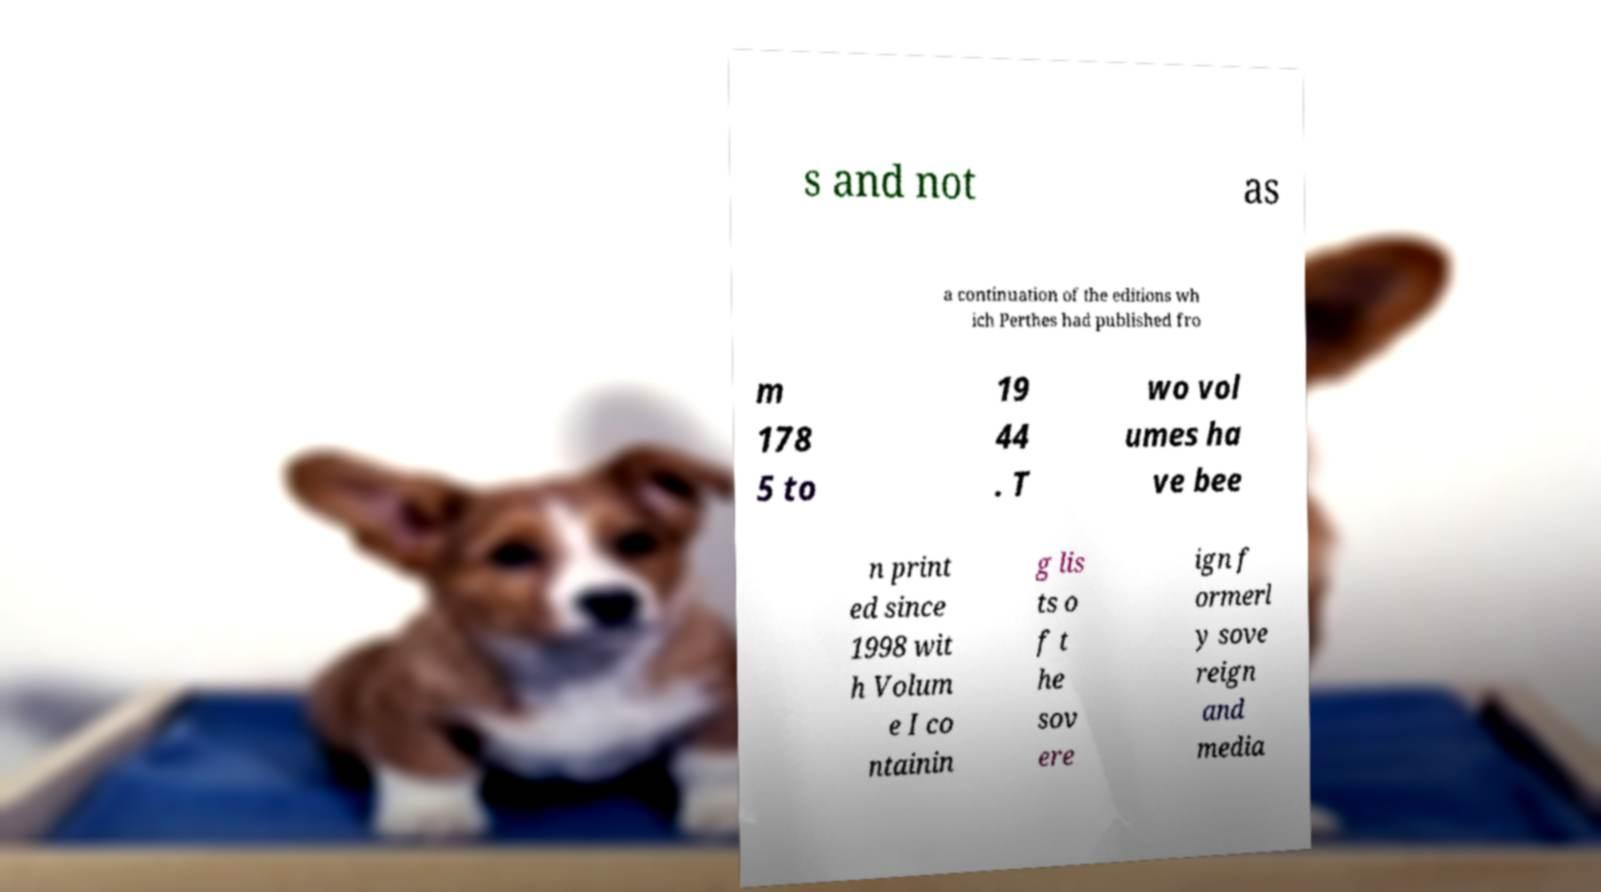There's text embedded in this image that I need extracted. Can you transcribe it verbatim? s and not as a continuation of the editions wh ich Perthes had published fro m 178 5 to 19 44 . T wo vol umes ha ve bee n print ed since 1998 wit h Volum e I co ntainin g lis ts o f t he sov ere ign f ormerl y sove reign and media 